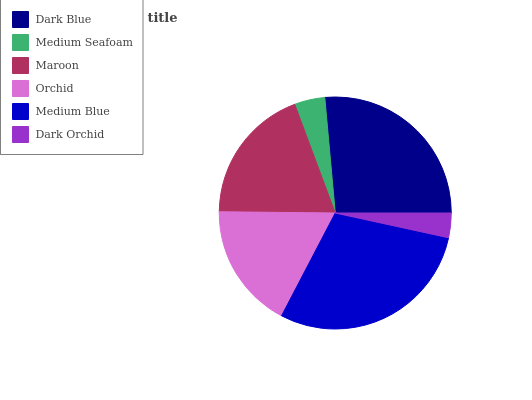Is Dark Orchid the minimum?
Answer yes or no. Yes. Is Medium Blue the maximum?
Answer yes or no. Yes. Is Medium Seafoam the minimum?
Answer yes or no. No. Is Medium Seafoam the maximum?
Answer yes or no. No. Is Dark Blue greater than Medium Seafoam?
Answer yes or no. Yes. Is Medium Seafoam less than Dark Blue?
Answer yes or no. Yes. Is Medium Seafoam greater than Dark Blue?
Answer yes or no. No. Is Dark Blue less than Medium Seafoam?
Answer yes or no. No. Is Maroon the high median?
Answer yes or no. Yes. Is Orchid the low median?
Answer yes or no. Yes. Is Medium Seafoam the high median?
Answer yes or no. No. Is Maroon the low median?
Answer yes or no. No. 